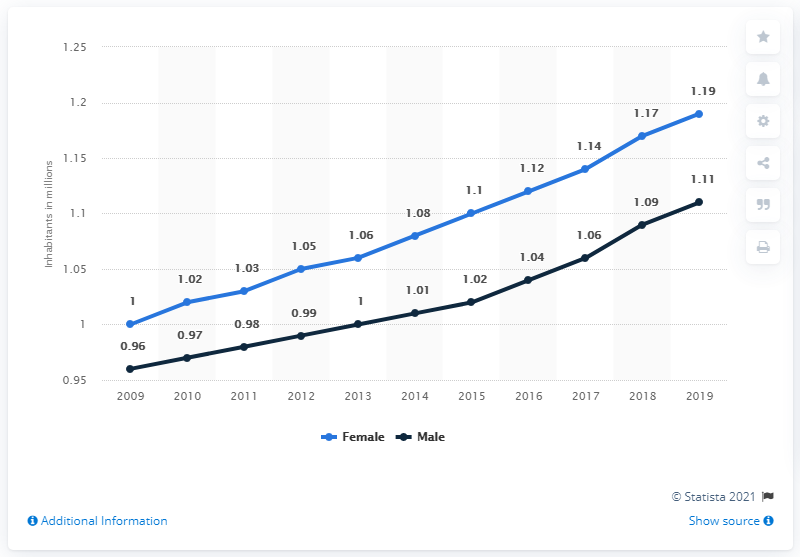Indicate a few pertinent items in this graphic. The light blue indicates that the gender is female. As of 2019, the male population of Botswana was 1.11 million. In 2018, the population was approximately 0.08 compared to the previous year. In 2019, the female population of Botswana was 1.19 million. 